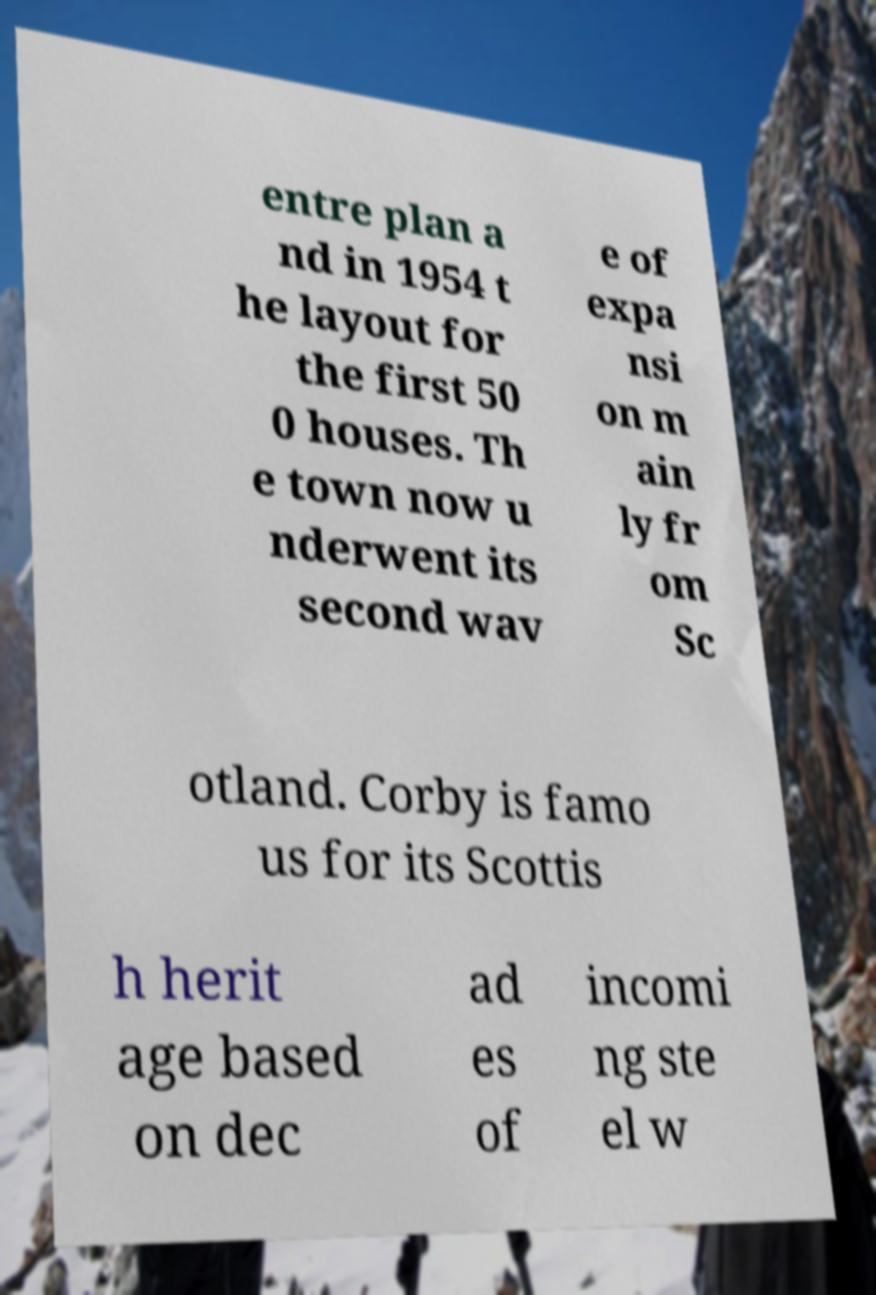Can you read and provide the text displayed in the image?This photo seems to have some interesting text. Can you extract and type it out for me? entre plan a nd in 1954 t he layout for the first 50 0 houses. Th e town now u nderwent its second wav e of expa nsi on m ain ly fr om Sc otland. Corby is famo us for its Scottis h herit age based on dec ad es of incomi ng ste el w 